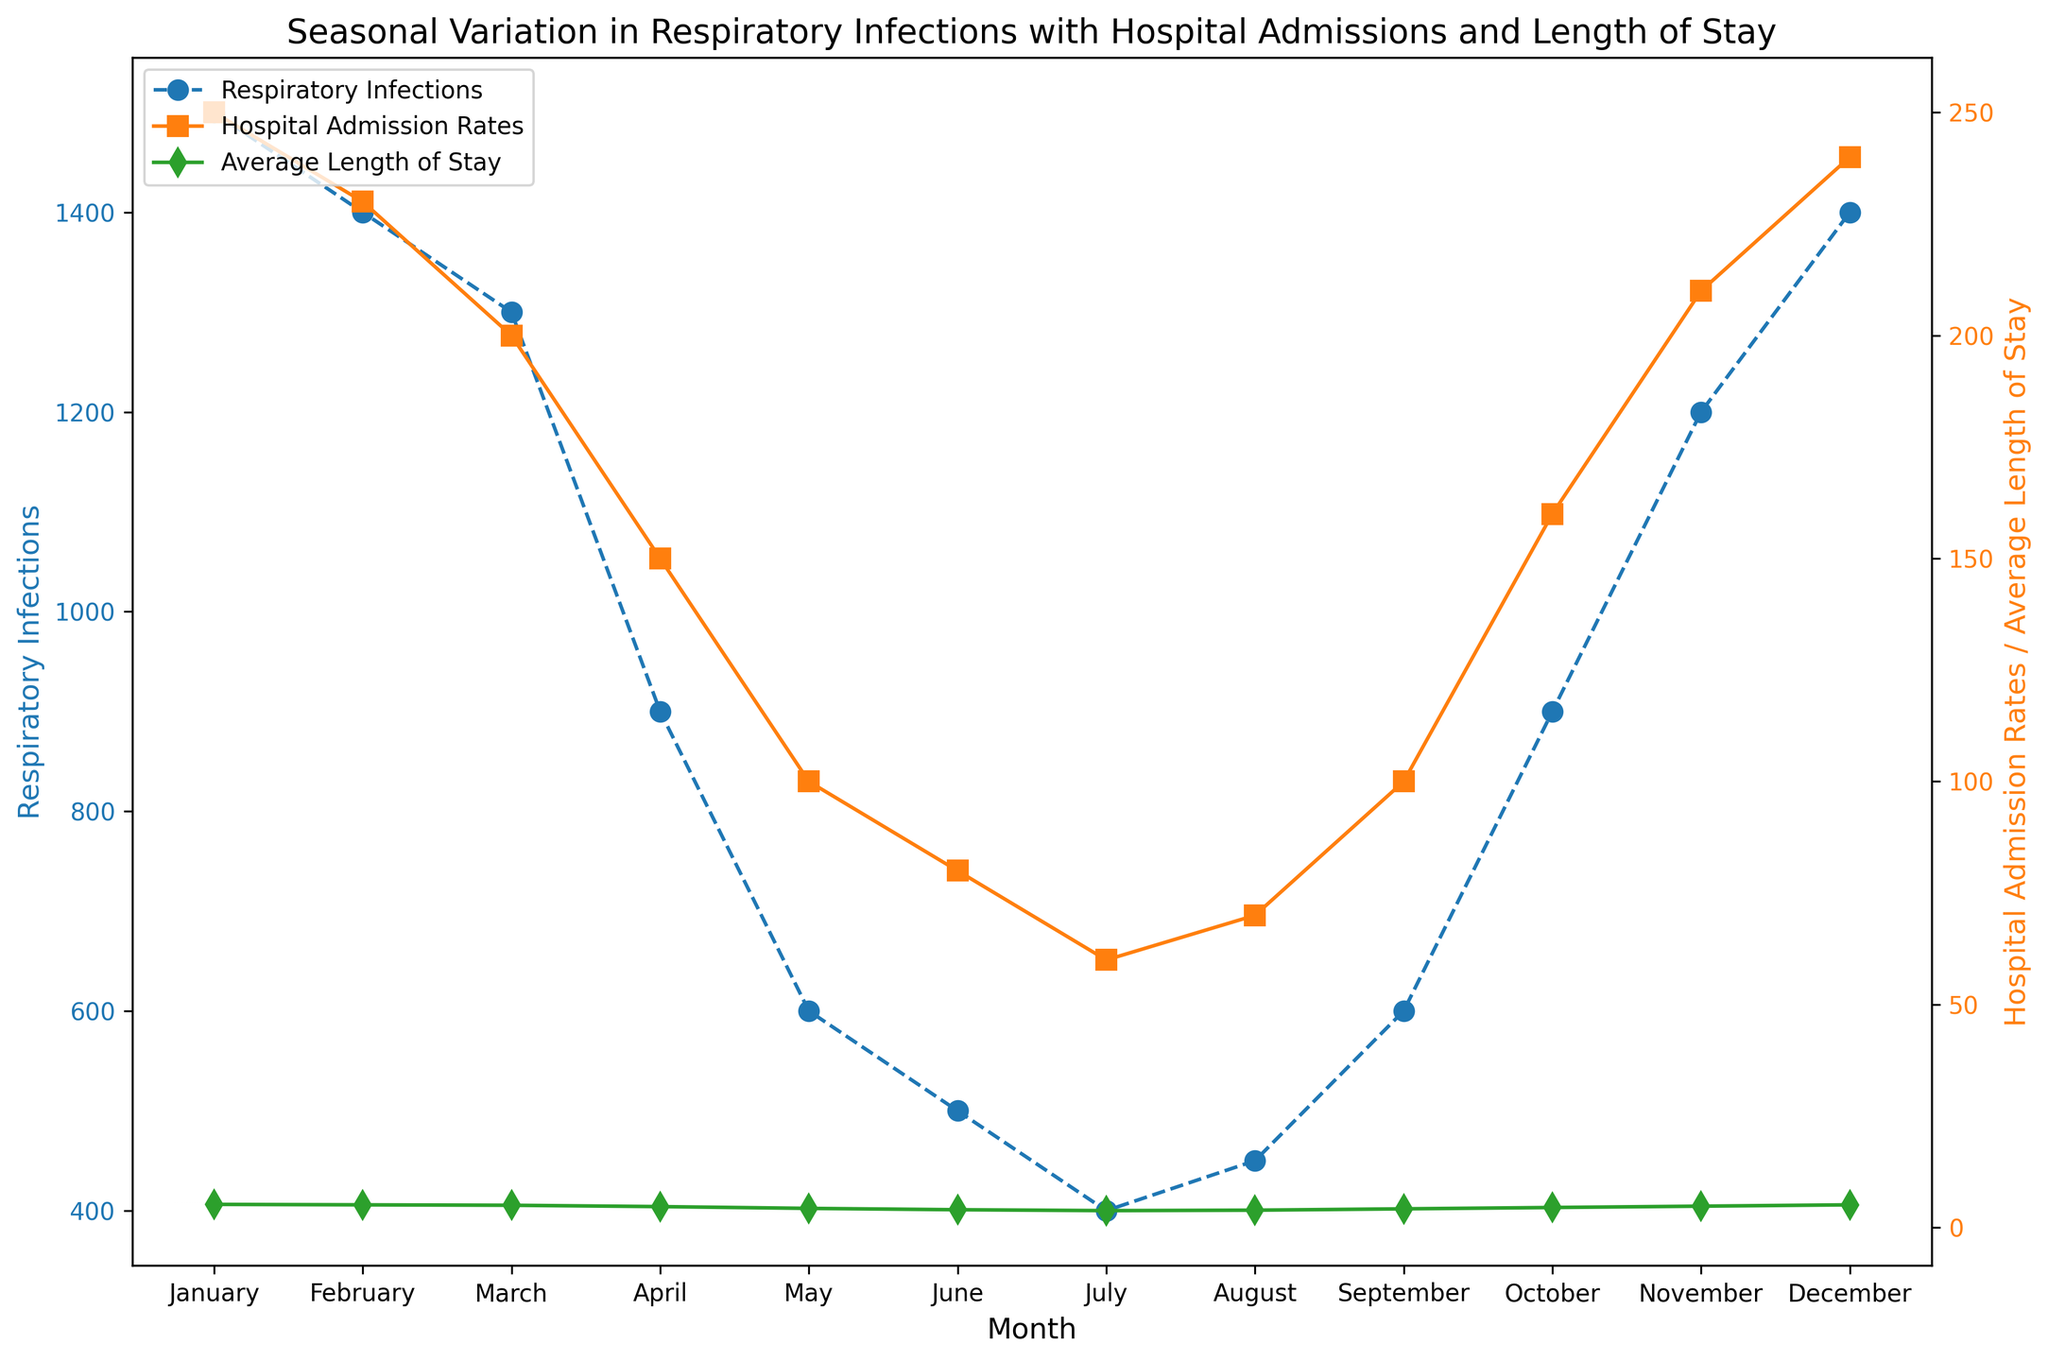Which month has the highest number of respiratory infections? Observing the blue line in the chart, the highest point corresponds to January.
Answer: January How many more hospital admissions were there in January compared to July? January has 250 admissions and July has 60, so the difference is 250 - 60 = 190.
Answer: 190 Which month shows the shortest average length of stay? The green line indicates the shortest average length of stay, which occurs in July at 3.8 days.
Answer: July Compare the hospital admission rates in April and October. Which one is higher, and by how much? In April, the admission rate is 150, and in October, it is 160. The difference is 160 - 150 = 10.
Answer: October, 10 During which month do respiratory infections start to significantly decline from their peak? The peak is in January at 1500. There is a significant drop in February to 1400 and further in March to 1300. The significant decline starts from February.
Answer: February What is the average length of stay in December, and how does it compare to June? December shows an average length of stay of 5.1 days, whereas June has 4.0 days. The difference is 5.1 - 4.0 = 1.1 days.
Answer: December, 1.1 days In which months do the hospital admission rates stay below 100? Observing the orange line, the months are May (100), June (80), July (60), and August (70).
Answer: May, June, July, August Which month shows the largest month-on-month increase in respiratory infections? There is a large increase from August (450) to September (600), which is an increase of 150.
Answer: September Compare respiratory infections in May and September. Which month has more infections and by how much? May has 600 infections, and September also has 600, so they are equal.
Answer: Equal How does the average length of stay trend change from March to April? The green line indicates the average length of stay drops from 5.0 in March to 4.7 in April.
Answer: Decreases 